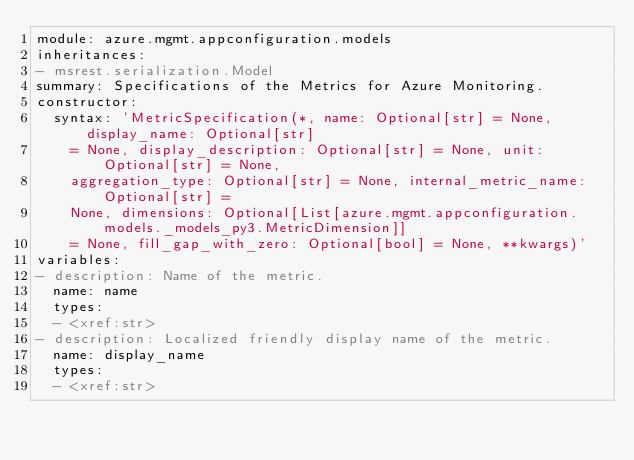<code> <loc_0><loc_0><loc_500><loc_500><_YAML_>module: azure.mgmt.appconfiguration.models
inheritances:
- msrest.serialization.Model
summary: Specifications of the Metrics for Azure Monitoring.
constructor:
  syntax: 'MetricSpecification(*, name: Optional[str] = None, display_name: Optional[str]
    = None, display_description: Optional[str] = None, unit: Optional[str] = None,
    aggregation_type: Optional[str] = None, internal_metric_name: Optional[str] =
    None, dimensions: Optional[List[azure.mgmt.appconfiguration.models._models_py3.MetricDimension]]
    = None, fill_gap_with_zero: Optional[bool] = None, **kwargs)'
variables:
- description: Name of the metric.
  name: name
  types:
  - <xref:str>
- description: Localized friendly display name of the metric.
  name: display_name
  types:
  - <xref:str></code> 